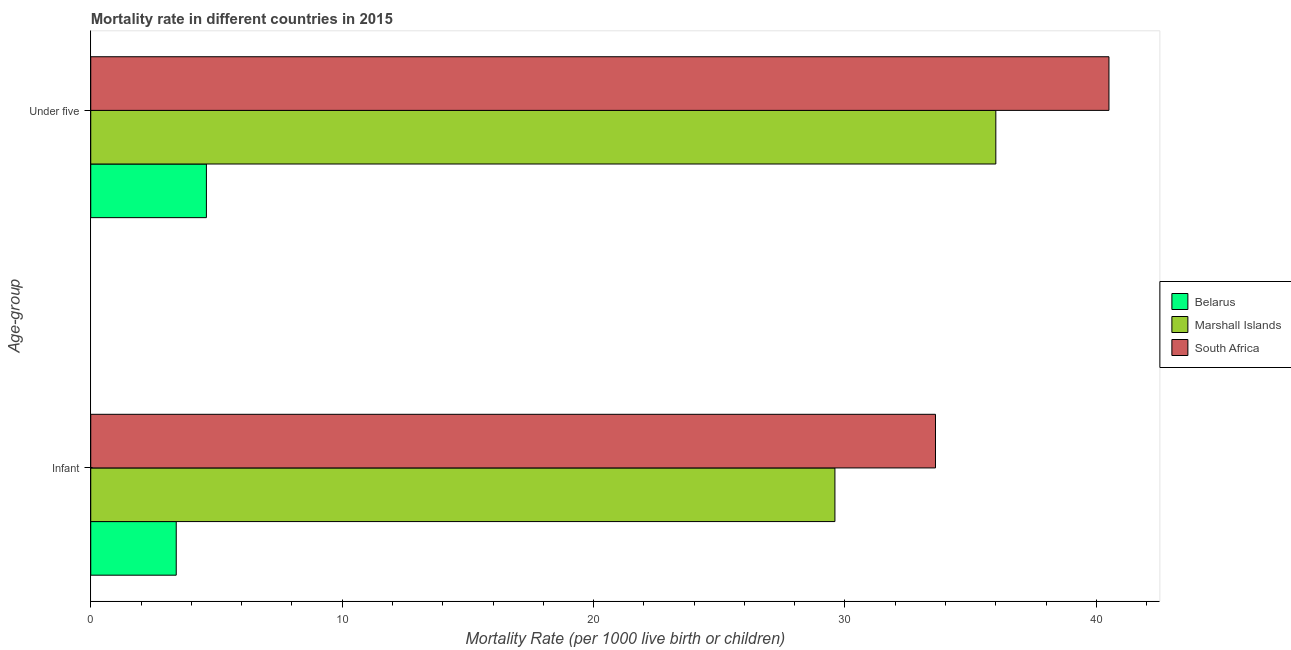How many different coloured bars are there?
Offer a very short reply. 3. Are the number of bars on each tick of the Y-axis equal?
Your answer should be compact. Yes. How many bars are there on the 2nd tick from the top?
Provide a succinct answer. 3. How many bars are there on the 2nd tick from the bottom?
Give a very brief answer. 3. What is the label of the 2nd group of bars from the top?
Your response must be concise. Infant. What is the infant mortality rate in Marshall Islands?
Keep it short and to the point. 29.6. Across all countries, what is the maximum under-5 mortality rate?
Ensure brevity in your answer.  40.5. In which country was the infant mortality rate maximum?
Your answer should be very brief. South Africa. In which country was the infant mortality rate minimum?
Make the answer very short. Belarus. What is the total under-5 mortality rate in the graph?
Provide a short and direct response. 81.1. What is the difference between the under-5 mortality rate in Belarus and that in South Africa?
Your response must be concise. -35.9. What is the difference between the infant mortality rate in Belarus and the under-5 mortality rate in Marshall Islands?
Your answer should be very brief. -32.6. What is the average under-5 mortality rate per country?
Give a very brief answer. 27.03. What is the difference between the infant mortality rate and under-5 mortality rate in Belarus?
Your answer should be very brief. -1.2. In how many countries, is the infant mortality rate greater than 36 ?
Provide a short and direct response. 0. What is the ratio of the under-5 mortality rate in South Africa to that in Belarus?
Make the answer very short. 8.8. Is the under-5 mortality rate in Marshall Islands less than that in South Africa?
Your response must be concise. Yes. What does the 1st bar from the top in Under five represents?
Your answer should be very brief. South Africa. What does the 1st bar from the bottom in Infant represents?
Provide a short and direct response. Belarus. Are all the bars in the graph horizontal?
Give a very brief answer. Yes. How many countries are there in the graph?
Make the answer very short. 3. What is the difference between two consecutive major ticks on the X-axis?
Give a very brief answer. 10. Are the values on the major ticks of X-axis written in scientific E-notation?
Give a very brief answer. No. Does the graph contain grids?
Your response must be concise. No. What is the title of the graph?
Provide a succinct answer. Mortality rate in different countries in 2015. What is the label or title of the X-axis?
Offer a very short reply. Mortality Rate (per 1000 live birth or children). What is the label or title of the Y-axis?
Offer a terse response. Age-group. What is the Mortality Rate (per 1000 live birth or children) of Belarus in Infant?
Keep it short and to the point. 3.4. What is the Mortality Rate (per 1000 live birth or children) of Marshall Islands in Infant?
Give a very brief answer. 29.6. What is the Mortality Rate (per 1000 live birth or children) of South Africa in Infant?
Ensure brevity in your answer.  33.6. What is the Mortality Rate (per 1000 live birth or children) in Marshall Islands in Under five?
Provide a succinct answer. 36. What is the Mortality Rate (per 1000 live birth or children) in South Africa in Under five?
Your answer should be compact. 40.5. Across all Age-group, what is the maximum Mortality Rate (per 1000 live birth or children) of Belarus?
Your answer should be very brief. 4.6. Across all Age-group, what is the maximum Mortality Rate (per 1000 live birth or children) in Marshall Islands?
Your response must be concise. 36. Across all Age-group, what is the maximum Mortality Rate (per 1000 live birth or children) in South Africa?
Your answer should be very brief. 40.5. Across all Age-group, what is the minimum Mortality Rate (per 1000 live birth or children) of Belarus?
Offer a terse response. 3.4. Across all Age-group, what is the minimum Mortality Rate (per 1000 live birth or children) of Marshall Islands?
Keep it short and to the point. 29.6. Across all Age-group, what is the minimum Mortality Rate (per 1000 live birth or children) of South Africa?
Give a very brief answer. 33.6. What is the total Mortality Rate (per 1000 live birth or children) of Belarus in the graph?
Offer a very short reply. 8. What is the total Mortality Rate (per 1000 live birth or children) in Marshall Islands in the graph?
Give a very brief answer. 65.6. What is the total Mortality Rate (per 1000 live birth or children) in South Africa in the graph?
Offer a terse response. 74.1. What is the difference between the Mortality Rate (per 1000 live birth or children) of Marshall Islands in Infant and that in Under five?
Provide a short and direct response. -6.4. What is the difference between the Mortality Rate (per 1000 live birth or children) of Belarus in Infant and the Mortality Rate (per 1000 live birth or children) of Marshall Islands in Under five?
Your answer should be compact. -32.6. What is the difference between the Mortality Rate (per 1000 live birth or children) of Belarus in Infant and the Mortality Rate (per 1000 live birth or children) of South Africa in Under five?
Provide a succinct answer. -37.1. What is the difference between the Mortality Rate (per 1000 live birth or children) in Marshall Islands in Infant and the Mortality Rate (per 1000 live birth or children) in South Africa in Under five?
Your answer should be compact. -10.9. What is the average Mortality Rate (per 1000 live birth or children) in Belarus per Age-group?
Provide a short and direct response. 4. What is the average Mortality Rate (per 1000 live birth or children) of Marshall Islands per Age-group?
Keep it short and to the point. 32.8. What is the average Mortality Rate (per 1000 live birth or children) in South Africa per Age-group?
Provide a short and direct response. 37.05. What is the difference between the Mortality Rate (per 1000 live birth or children) in Belarus and Mortality Rate (per 1000 live birth or children) in Marshall Islands in Infant?
Give a very brief answer. -26.2. What is the difference between the Mortality Rate (per 1000 live birth or children) of Belarus and Mortality Rate (per 1000 live birth or children) of South Africa in Infant?
Your answer should be compact. -30.2. What is the difference between the Mortality Rate (per 1000 live birth or children) in Belarus and Mortality Rate (per 1000 live birth or children) in Marshall Islands in Under five?
Your response must be concise. -31.4. What is the difference between the Mortality Rate (per 1000 live birth or children) in Belarus and Mortality Rate (per 1000 live birth or children) in South Africa in Under five?
Make the answer very short. -35.9. What is the difference between the Mortality Rate (per 1000 live birth or children) of Marshall Islands and Mortality Rate (per 1000 live birth or children) of South Africa in Under five?
Provide a succinct answer. -4.5. What is the ratio of the Mortality Rate (per 1000 live birth or children) of Belarus in Infant to that in Under five?
Provide a short and direct response. 0.74. What is the ratio of the Mortality Rate (per 1000 live birth or children) in Marshall Islands in Infant to that in Under five?
Keep it short and to the point. 0.82. What is the ratio of the Mortality Rate (per 1000 live birth or children) of South Africa in Infant to that in Under five?
Ensure brevity in your answer.  0.83. What is the difference between the highest and the second highest Mortality Rate (per 1000 live birth or children) in South Africa?
Ensure brevity in your answer.  6.9. What is the difference between the highest and the lowest Mortality Rate (per 1000 live birth or children) of Belarus?
Provide a short and direct response. 1.2. What is the difference between the highest and the lowest Mortality Rate (per 1000 live birth or children) in Marshall Islands?
Your answer should be compact. 6.4. What is the difference between the highest and the lowest Mortality Rate (per 1000 live birth or children) of South Africa?
Your answer should be very brief. 6.9. 